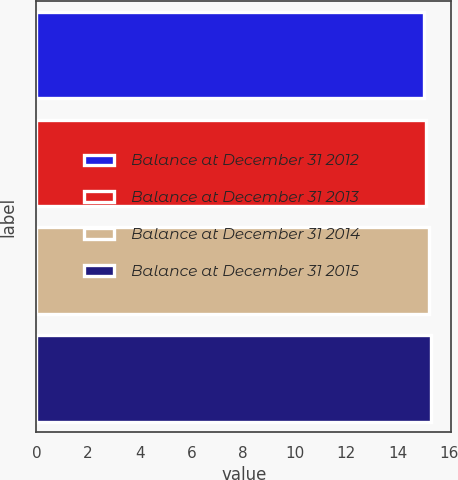Convert chart to OTSL. <chart><loc_0><loc_0><loc_500><loc_500><bar_chart><fcel>Balance at December 31 2012<fcel>Balance at December 31 2013<fcel>Balance at December 31 2014<fcel>Balance at December 31 2015<nl><fcel>15<fcel>15.1<fcel>15.2<fcel>15.3<nl></chart> 